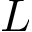Convert formula to latex. <formula><loc_0><loc_0><loc_500><loc_500>L</formula> 